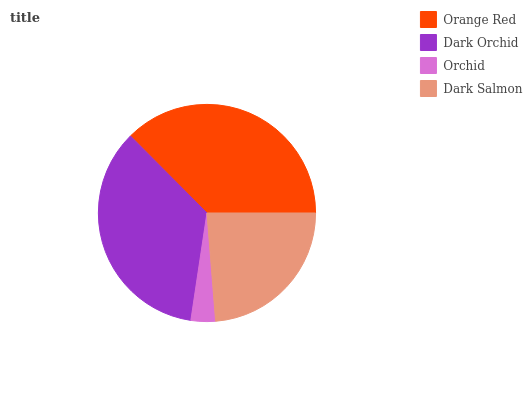Is Orchid the minimum?
Answer yes or no. Yes. Is Orange Red the maximum?
Answer yes or no. Yes. Is Dark Orchid the minimum?
Answer yes or no. No. Is Dark Orchid the maximum?
Answer yes or no. No. Is Orange Red greater than Dark Orchid?
Answer yes or no. Yes. Is Dark Orchid less than Orange Red?
Answer yes or no. Yes. Is Dark Orchid greater than Orange Red?
Answer yes or no. No. Is Orange Red less than Dark Orchid?
Answer yes or no. No. Is Dark Orchid the high median?
Answer yes or no. Yes. Is Dark Salmon the low median?
Answer yes or no. Yes. Is Dark Salmon the high median?
Answer yes or no. No. Is Orange Red the low median?
Answer yes or no. No. 